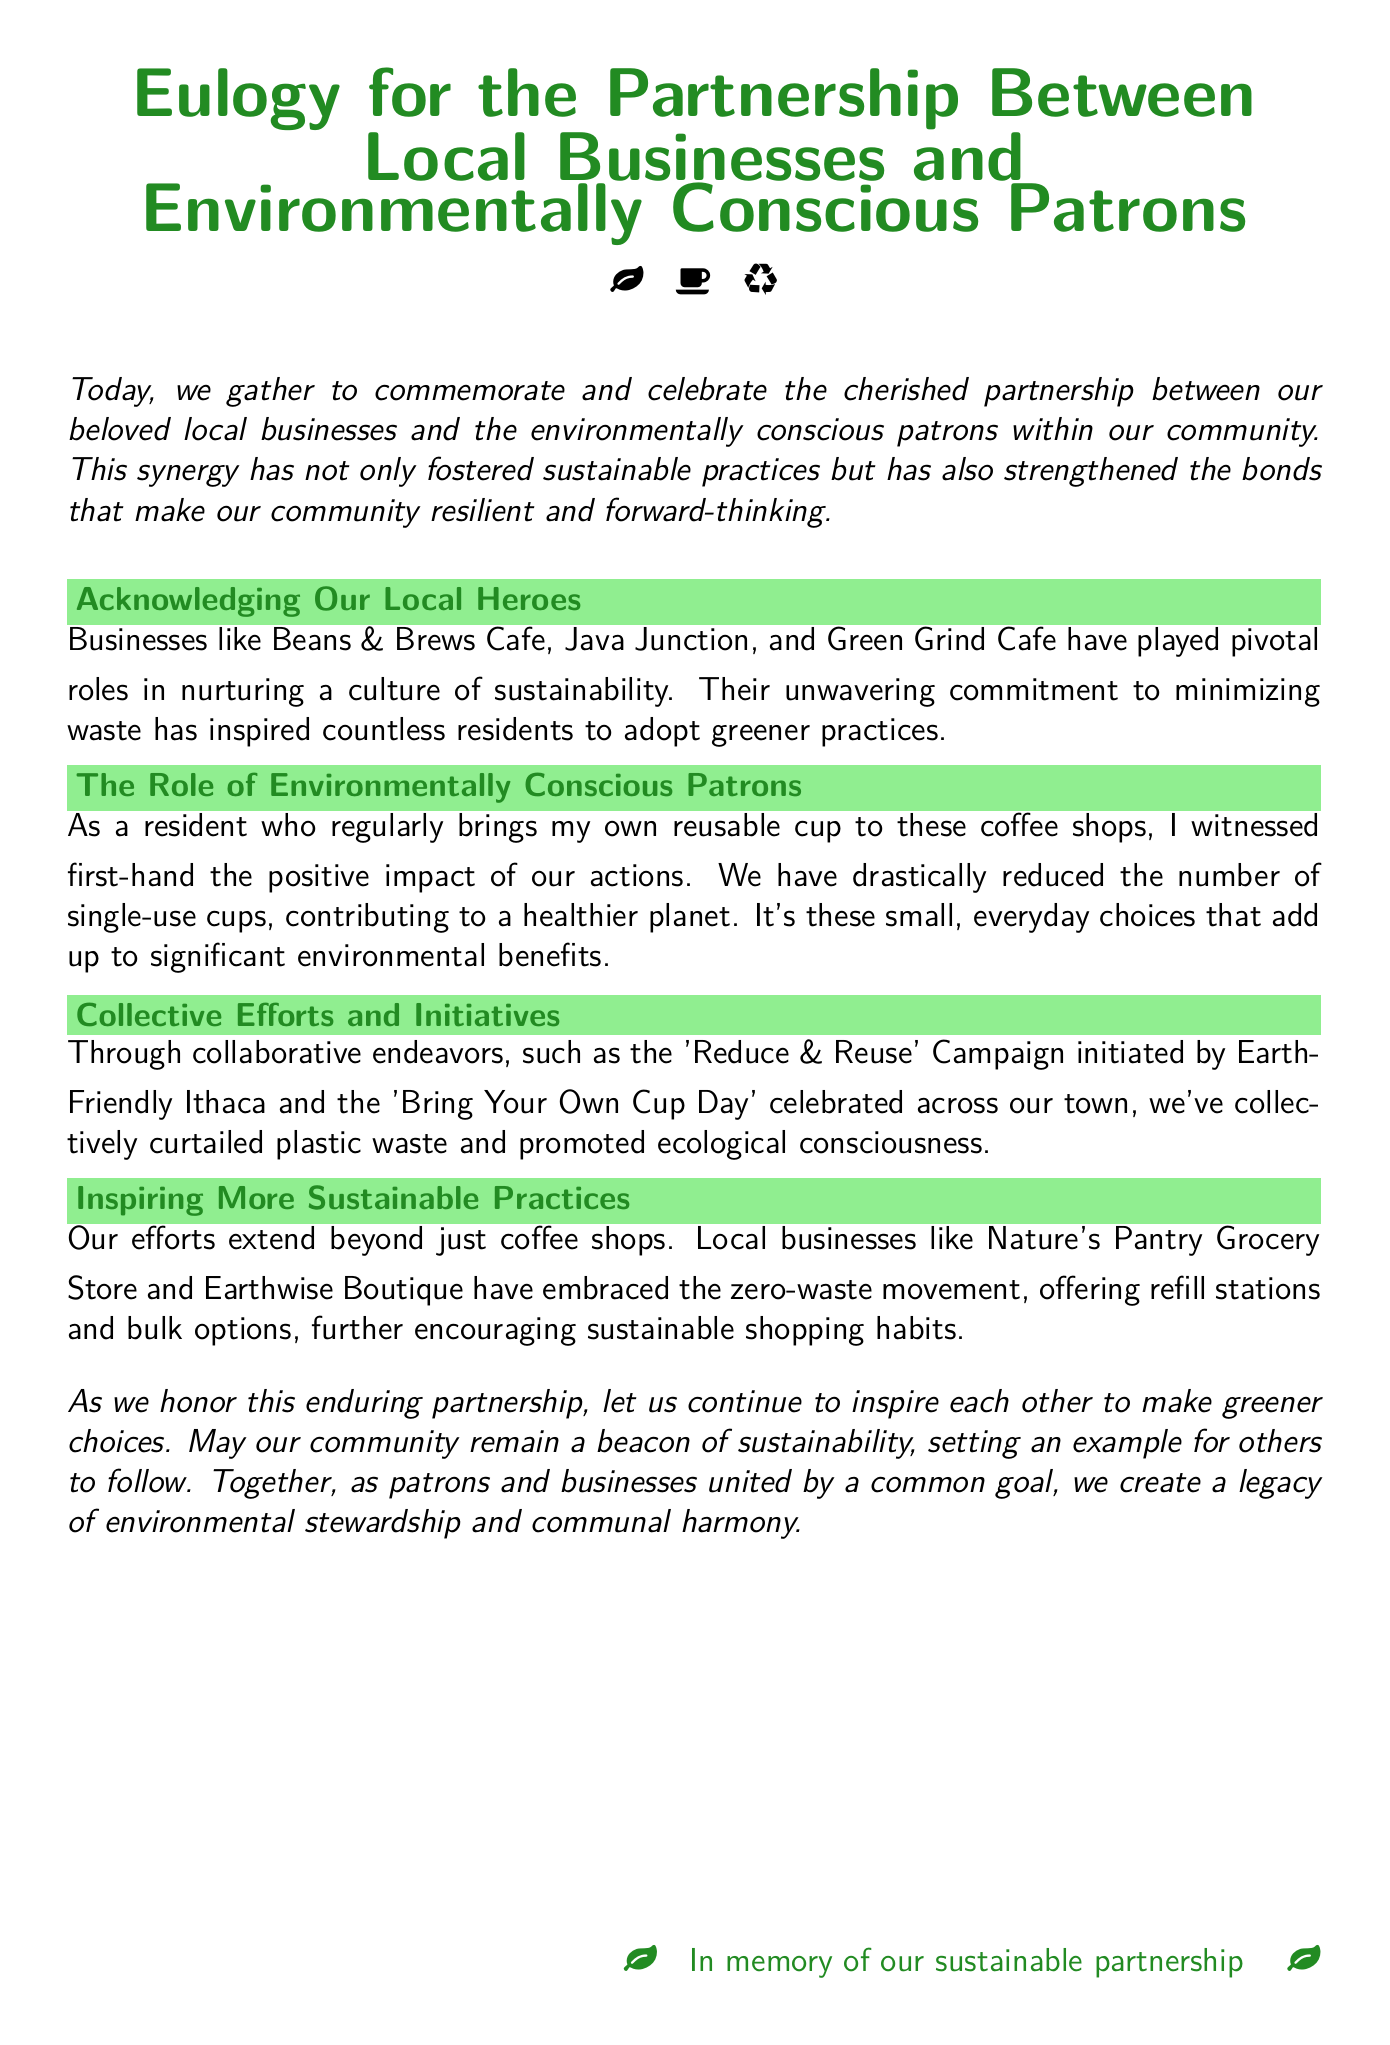What businesses are mentioned in the eulogy? The eulogy acknowledges Beans & Brews Cafe, Java Junction, and Green Grind Cafe as local businesses.
Answer: Beans & Brews Cafe, Java Junction, Green Grind Cafe What campaign is initiated by Earth-Friendly Ithaca? The eulogy refers to the 'Reduce & Reuse' Campaign as an initiative.
Answer: Reduce & Reuse Campaign How have patrons contributed to environmental efforts? The document states patrons have drastically reduced the number of single-use cups.
Answer: Reduced single-use cups Which movement have local businesses like Nature's Pantry Grocery Store embraced? The eulogy mentions that these businesses have embraced the zero-waste movement.
Answer: Zero-waste movement What is the primary focus of the eulogy? The eulogy commemorates and celebrates the partnership between local businesses and environmentally conscious patrons.
Answer: Partnership What common goal is highlighted in the conclusion of the document? The conclusion emphasizes creating a legacy of environmental stewardship and communal harmony.
Answer: Environmental stewardship 